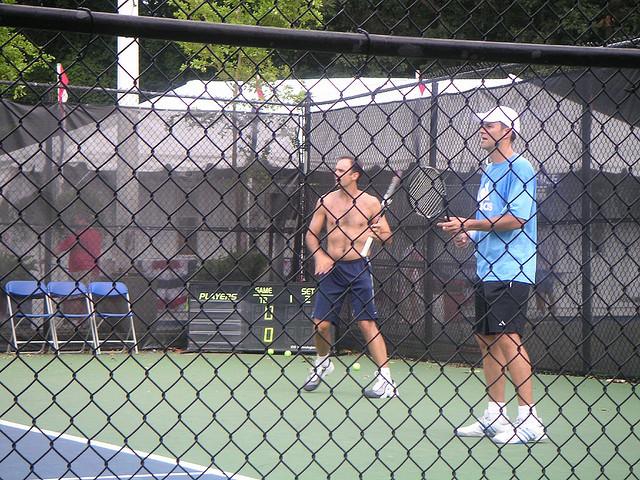How many men are wearing hats?
Give a very brief answer. 1. Are both men wearing shirts?
Concise answer only. No. Are the men on the same team?
Give a very brief answer. Yes. 